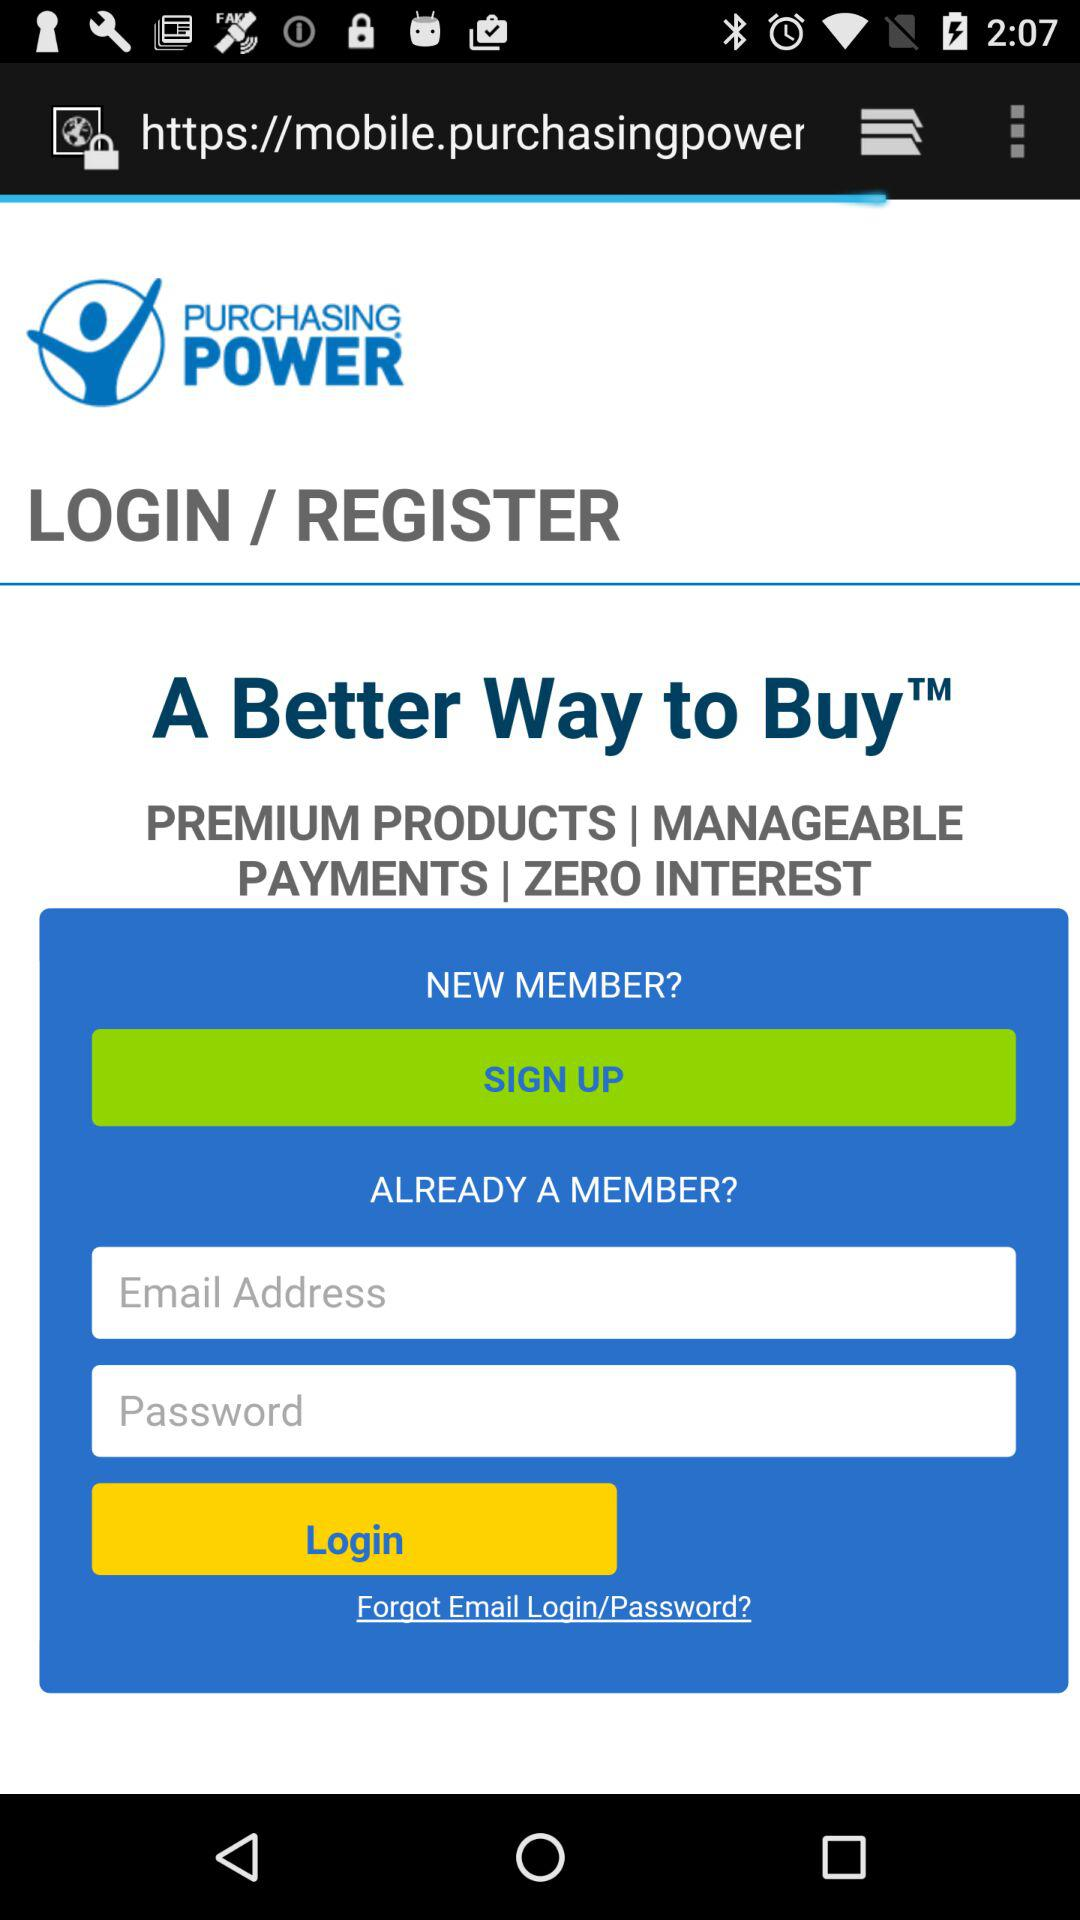When is the user signing up or logging in?
When the provided information is insufficient, respond with <no answer>. <no answer> 